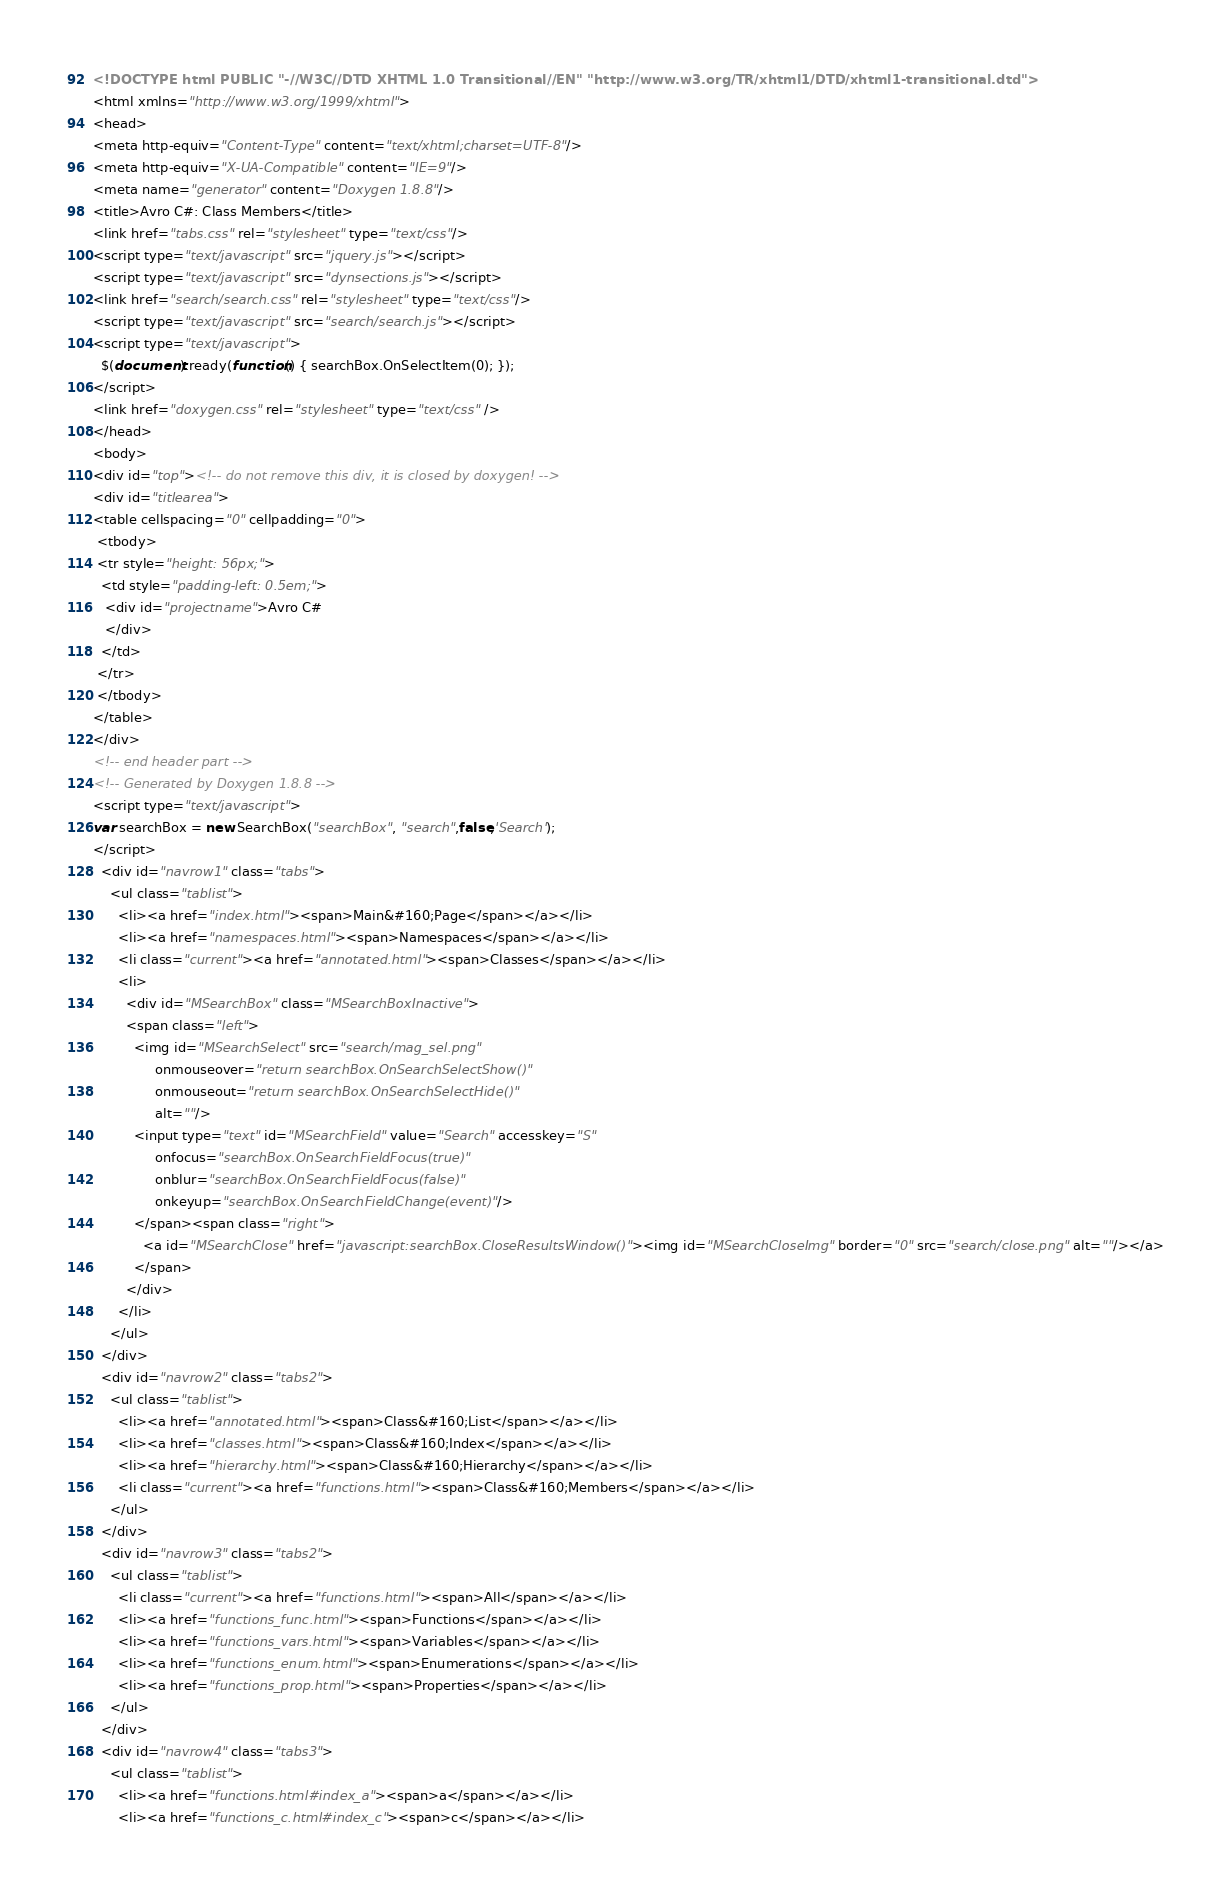<code> <loc_0><loc_0><loc_500><loc_500><_HTML_><!DOCTYPE html PUBLIC "-//W3C//DTD XHTML 1.0 Transitional//EN" "http://www.w3.org/TR/xhtml1/DTD/xhtml1-transitional.dtd">
<html xmlns="http://www.w3.org/1999/xhtml">
<head>
<meta http-equiv="Content-Type" content="text/xhtml;charset=UTF-8"/>
<meta http-equiv="X-UA-Compatible" content="IE=9"/>
<meta name="generator" content="Doxygen 1.8.8"/>
<title>Avro C#: Class Members</title>
<link href="tabs.css" rel="stylesheet" type="text/css"/>
<script type="text/javascript" src="jquery.js"></script>
<script type="text/javascript" src="dynsections.js"></script>
<link href="search/search.css" rel="stylesheet" type="text/css"/>
<script type="text/javascript" src="search/search.js"></script>
<script type="text/javascript">
  $(document).ready(function() { searchBox.OnSelectItem(0); });
</script>
<link href="doxygen.css" rel="stylesheet" type="text/css" />
</head>
<body>
<div id="top"><!-- do not remove this div, it is closed by doxygen! -->
<div id="titlearea">
<table cellspacing="0" cellpadding="0">
 <tbody>
 <tr style="height: 56px;">
  <td style="padding-left: 0.5em;">
   <div id="projectname">Avro C#
   </div>
  </td>
 </tr>
 </tbody>
</table>
</div>
<!-- end header part -->
<!-- Generated by Doxygen 1.8.8 -->
<script type="text/javascript">
var searchBox = new SearchBox("searchBox", "search",false,'Search');
</script>
  <div id="navrow1" class="tabs">
    <ul class="tablist">
      <li><a href="index.html"><span>Main&#160;Page</span></a></li>
      <li><a href="namespaces.html"><span>Namespaces</span></a></li>
      <li class="current"><a href="annotated.html"><span>Classes</span></a></li>
      <li>
        <div id="MSearchBox" class="MSearchBoxInactive">
        <span class="left">
          <img id="MSearchSelect" src="search/mag_sel.png"
               onmouseover="return searchBox.OnSearchSelectShow()"
               onmouseout="return searchBox.OnSearchSelectHide()"
               alt=""/>
          <input type="text" id="MSearchField" value="Search" accesskey="S"
               onfocus="searchBox.OnSearchFieldFocus(true)" 
               onblur="searchBox.OnSearchFieldFocus(false)" 
               onkeyup="searchBox.OnSearchFieldChange(event)"/>
          </span><span class="right">
            <a id="MSearchClose" href="javascript:searchBox.CloseResultsWindow()"><img id="MSearchCloseImg" border="0" src="search/close.png" alt=""/></a>
          </span>
        </div>
      </li>
    </ul>
  </div>
  <div id="navrow2" class="tabs2">
    <ul class="tablist">
      <li><a href="annotated.html"><span>Class&#160;List</span></a></li>
      <li><a href="classes.html"><span>Class&#160;Index</span></a></li>
      <li><a href="hierarchy.html"><span>Class&#160;Hierarchy</span></a></li>
      <li class="current"><a href="functions.html"><span>Class&#160;Members</span></a></li>
    </ul>
  </div>
  <div id="navrow3" class="tabs2">
    <ul class="tablist">
      <li class="current"><a href="functions.html"><span>All</span></a></li>
      <li><a href="functions_func.html"><span>Functions</span></a></li>
      <li><a href="functions_vars.html"><span>Variables</span></a></li>
      <li><a href="functions_enum.html"><span>Enumerations</span></a></li>
      <li><a href="functions_prop.html"><span>Properties</span></a></li>
    </ul>
  </div>
  <div id="navrow4" class="tabs3">
    <ul class="tablist">
      <li><a href="functions.html#index_a"><span>a</span></a></li>
      <li><a href="functions_c.html#index_c"><span>c</span></a></li></code> 